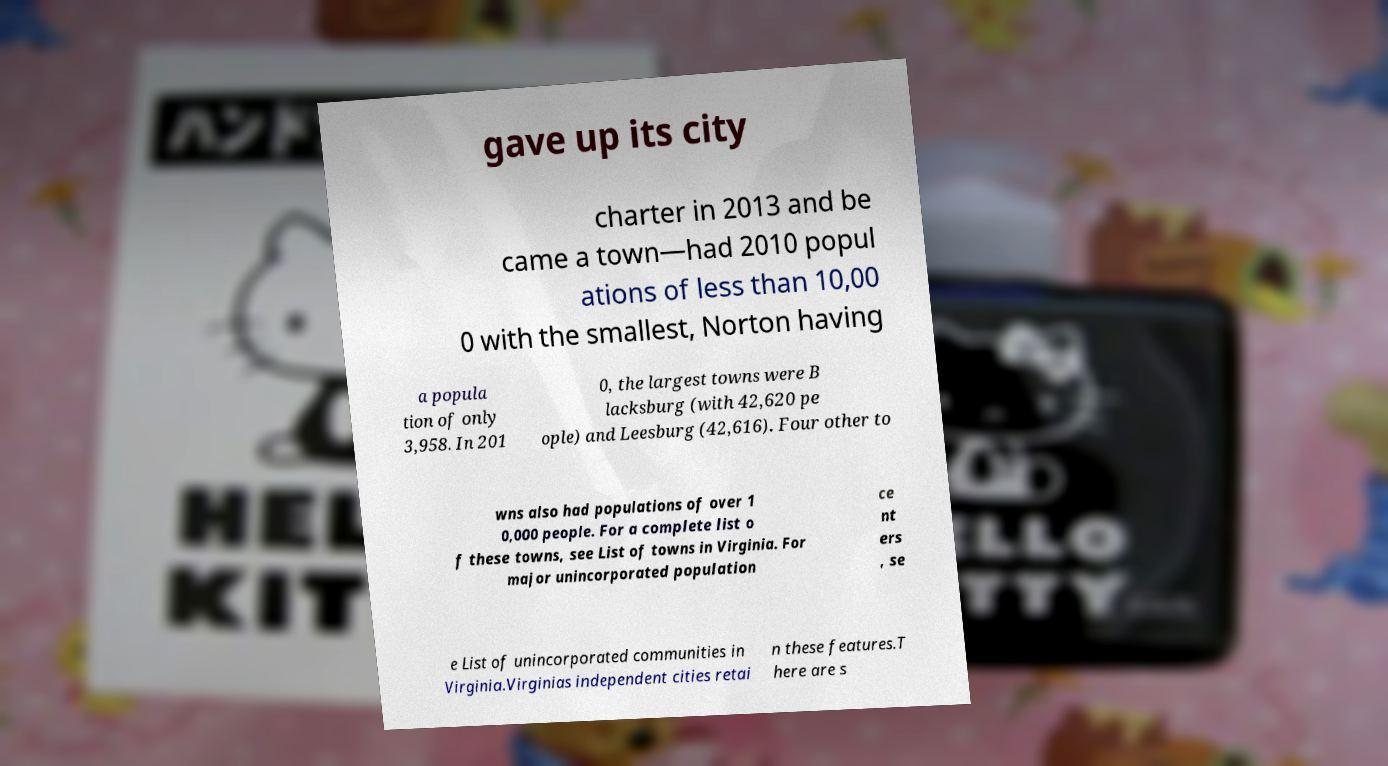Please read and relay the text visible in this image. What does it say? gave up its city charter in 2013 and be came a town—had 2010 popul ations of less than 10,00 0 with the smallest, Norton having a popula tion of only 3,958. In 201 0, the largest towns were B lacksburg (with 42,620 pe ople) and Leesburg (42,616). Four other to wns also had populations of over 1 0,000 people. For a complete list o f these towns, see List of towns in Virginia. For major unincorporated population ce nt ers , se e List of unincorporated communities in Virginia.Virginias independent cities retai n these features.T here are s 